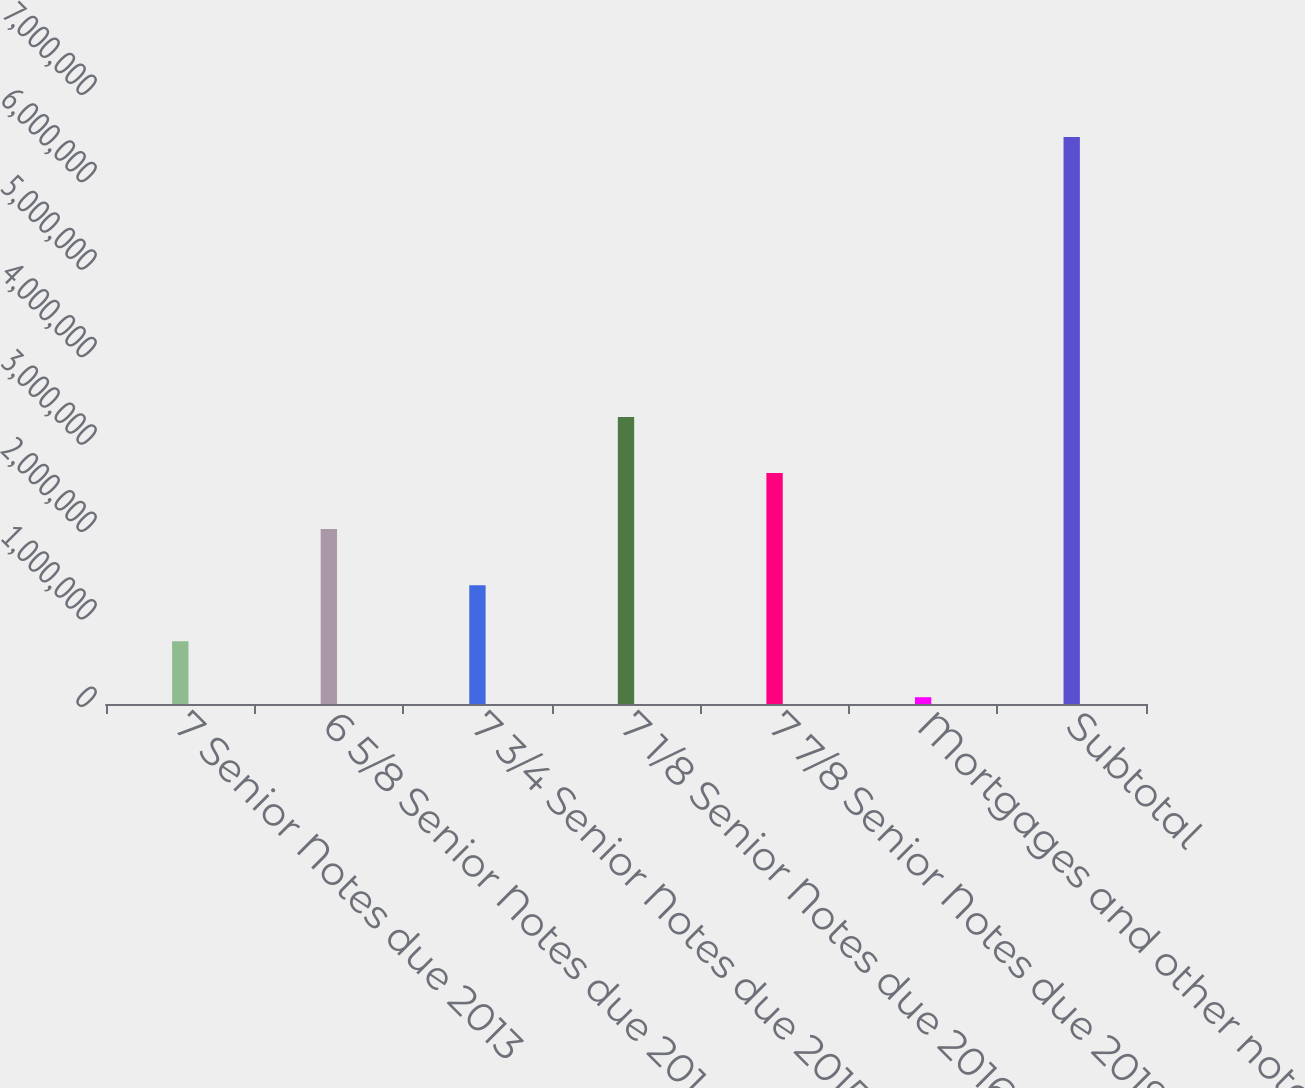<chart> <loc_0><loc_0><loc_500><loc_500><bar_chart><fcel>7 Senior Notes due 2013<fcel>6 5/8 Senior Notes due 2014<fcel>7 3/4 Senior Notes due 2015<fcel>7 1/8 Senior Notes due 2016<fcel>7 7/8 Senior Notes due 2019<fcel>Mortgages and other notes<fcel>Subtotal<nl><fcel>718782<fcel>2.00041e+06<fcel>1.3596e+06<fcel>3.28205e+06<fcel>2.64123e+06<fcel>77965<fcel>6.48613e+06<nl></chart> 